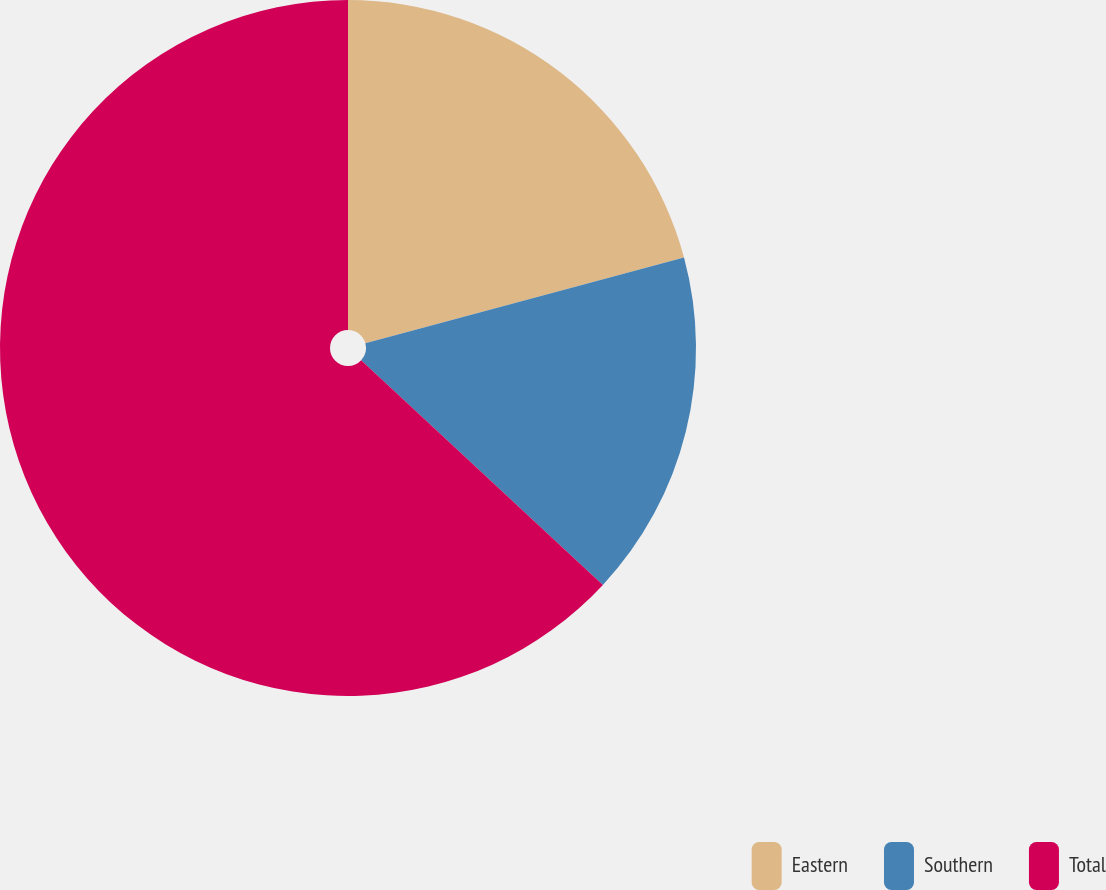<chart> <loc_0><loc_0><loc_500><loc_500><pie_chart><fcel>Eastern<fcel>Southern<fcel>Total<nl><fcel>20.81%<fcel>16.11%<fcel>63.08%<nl></chart> 